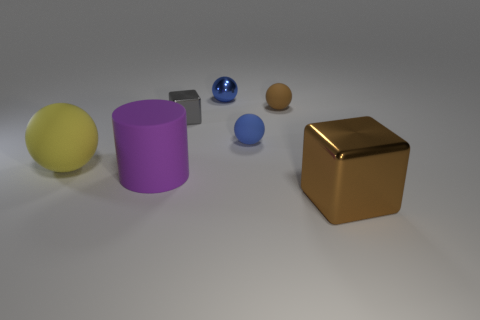There is a small metallic object that is the same shape as the tiny blue matte object; what is its color?
Ensure brevity in your answer.  Blue. What shape is the big thing that is right of the shiny cube behind the metal object that is in front of the small gray object?
Make the answer very short. Cube. Does the yellow matte object have the same shape as the brown matte object?
Make the answer very short. Yes. The large rubber object right of the ball that is to the left of the purple matte object is what shape?
Ensure brevity in your answer.  Cylinder. Are there any brown blocks?
Your response must be concise. Yes. There is a metallic block that is in front of the shiny block that is behind the big yellow matte object; what number of big matte balls are in front of it?
Give a very brief answer. 0. Do the brown metallic object and the brown object that is left of the large brown block have the same shape?
Provide a succinct answer. No. Is the number of tiny brown rubber balls greater than the number of big red objects?
Provide a short and direct response. Yes. There is a brown object on the left side of the brown block; is its shape the same as the purple thing?
Your answer should be compact. No. Is the number of tiny blue rubber things that are in front of the yellow rubber sphere greater than the number of large red things?
Keep it short and to the point. No. 